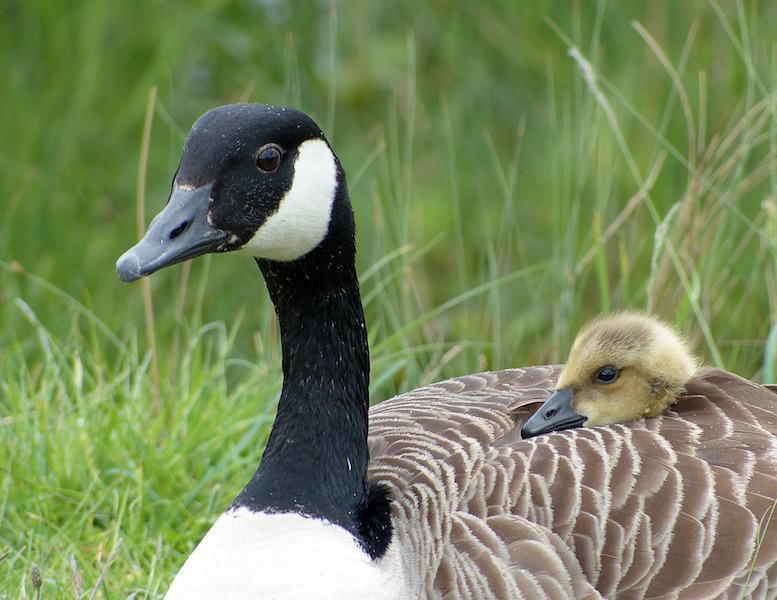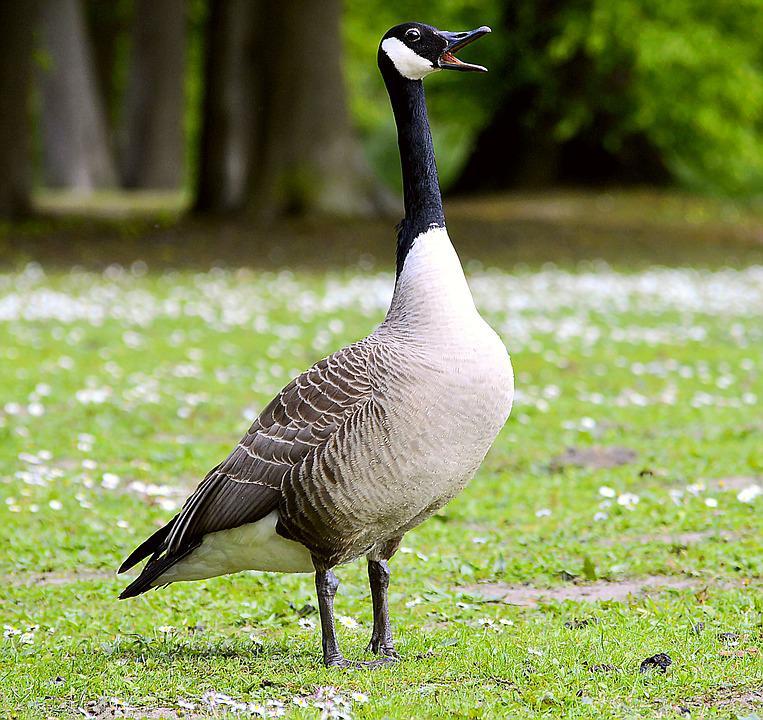The first image is the image on the left, the second image is the image on the right. Evaluate the accuracy of this statement regarding the images: "the goose on the right image is facing right". Is it true? Answer yes or no. Yes. 